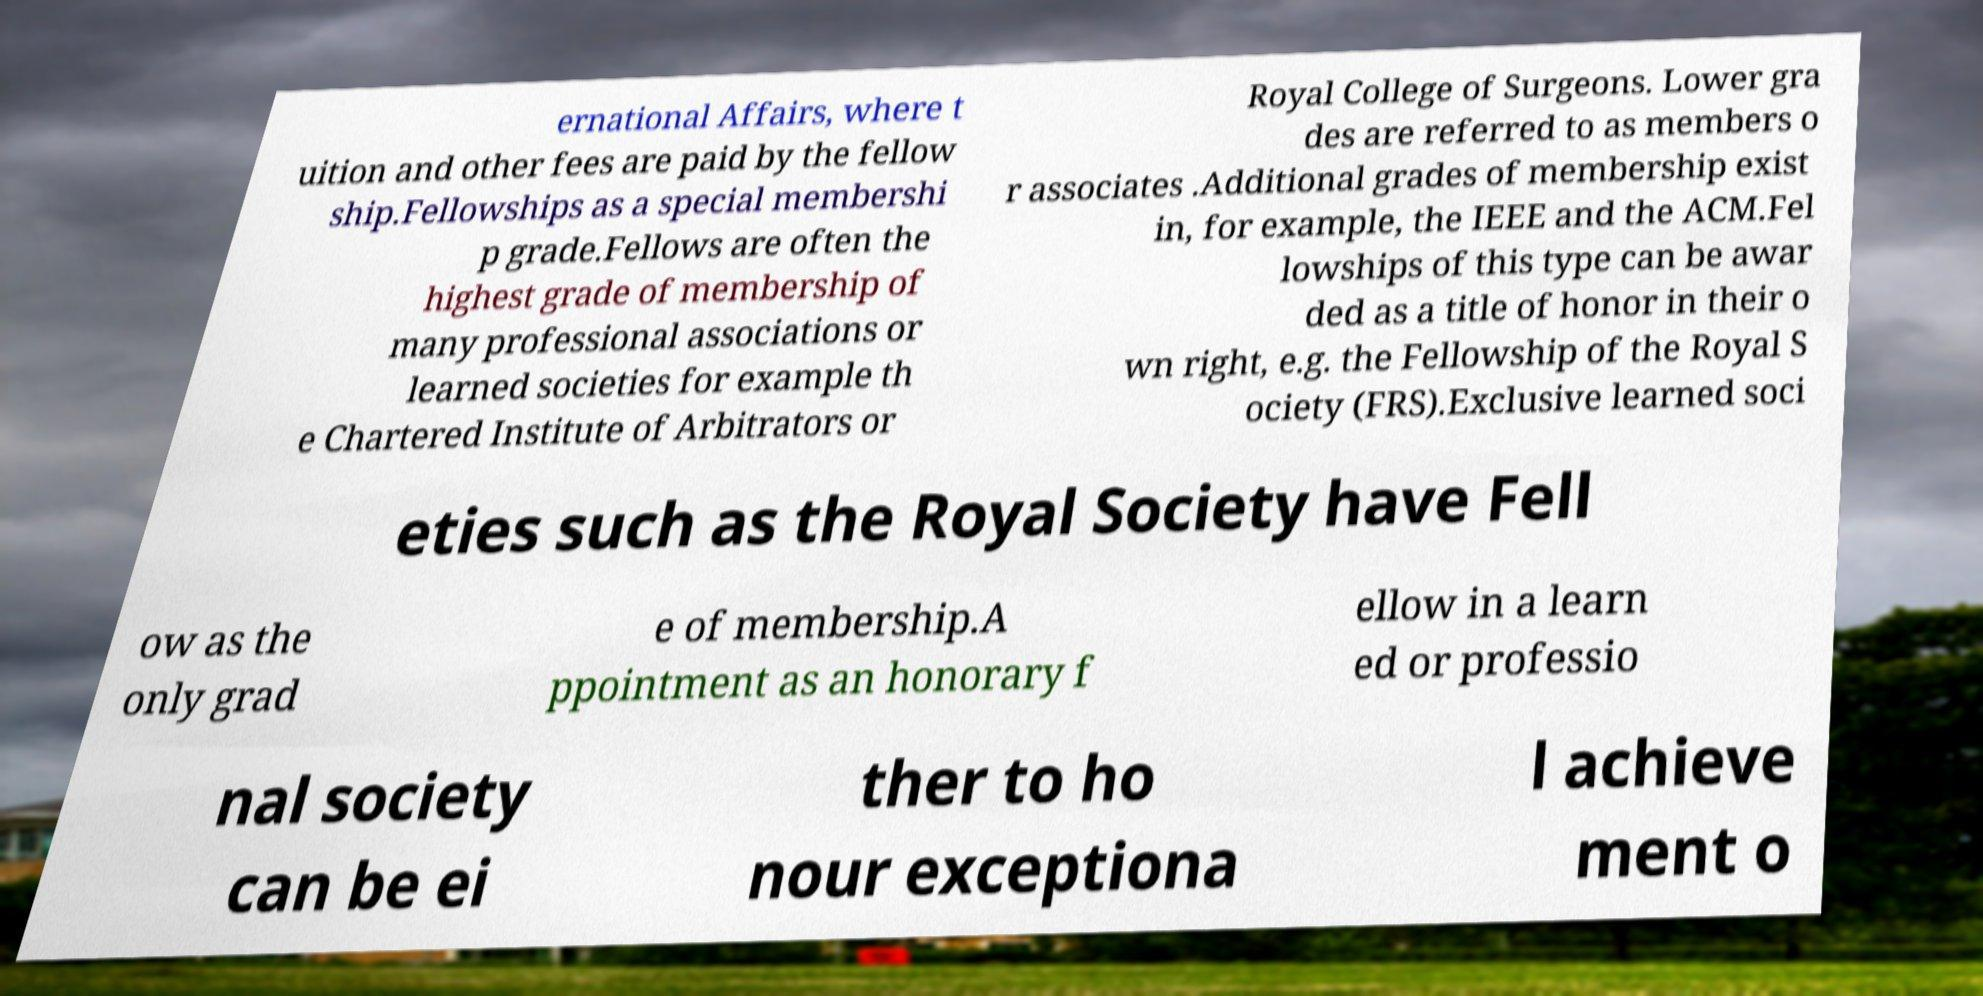Can you accurately transcribe the text from the provided image for me? ernational Affairs, where t uition and other fees are paid by the fellow ship.Fellowships as a special membershi p grade.Fellows are often the highest grade of membership of many professional associations or learned societies for example th e Chartered Institute of Arbitrators or Royal College of Surgeons. Lower gra des are referred to as members o r associates .Additional grades of membership exist in, for example, the IEEE and the ACM.Fel lowships of this type can be awar ded as a title of honor in their o wn right, e.g. the Fellowship of the Royal S ociety (FRS).Exclusive learned soci eties such as the Royal Society have Fell ow as the only grad e of membership.A ppointment as an honorary f ellow in a learn ed or professio nal society can be ei ther to ho nour exceptiona l achieve ment o 